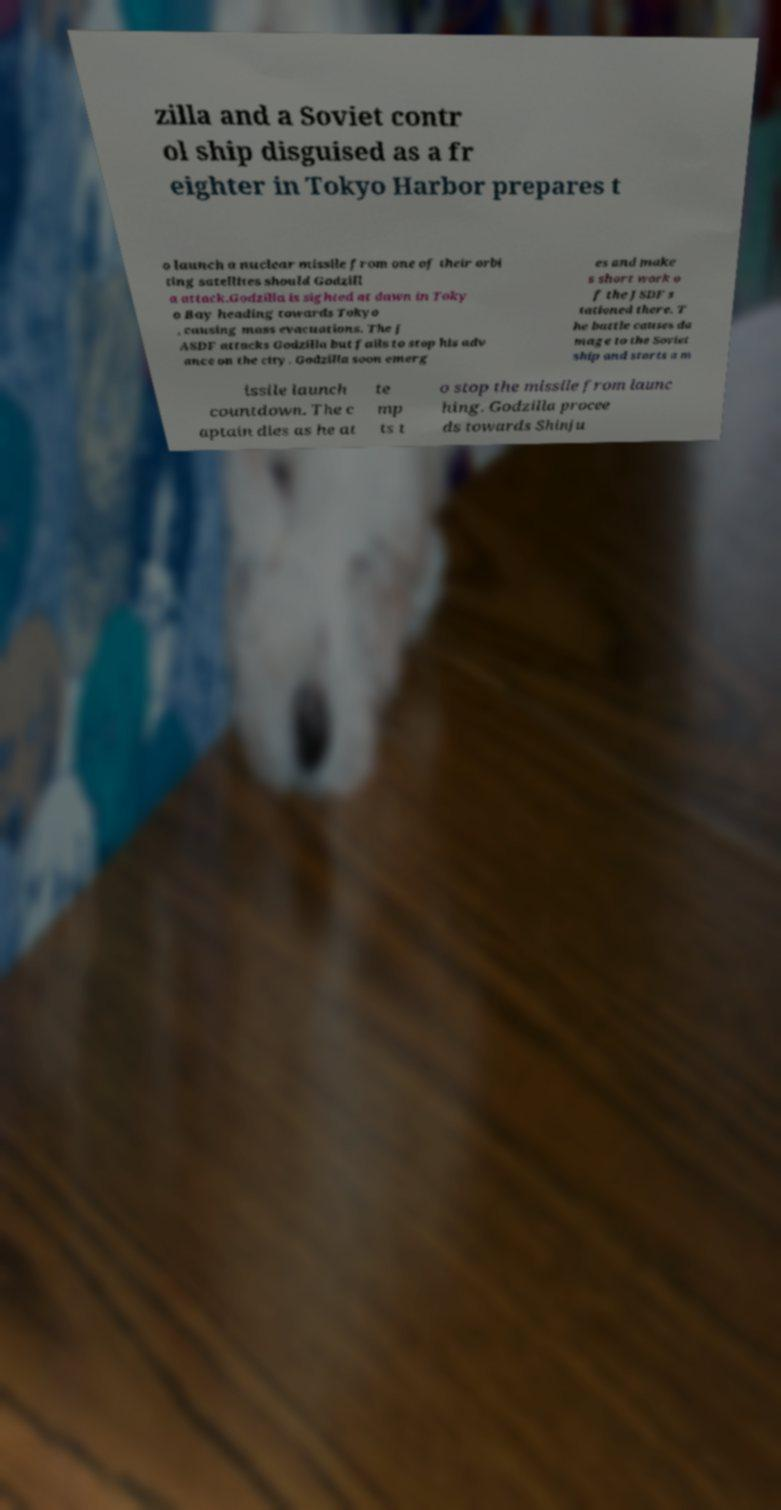Please identify and transcribe the text found in this image. zilla and a Soviet contr ol ship disguised as a fr eighter in Tokyo Harbor prepares t o launch a nuclear missile from one of their orbi ting satellites should Godzill a attack.Godzilla is sighted at dawn in Toky o Bay heading towards Tokyo , causing mass evacuations. The J ASDF attacks Godzilla but fails to stop his adv ance on the city. Godzilla soon emerg es and make s short work o f the JSDF s tationed there. T he battle causes da mage to the Soviet ship and starts a m issile launch countdown. The c aptain dies as he at te mp ts t o stop the missile from launc hing. Godzilla procee ds towards Shinju 